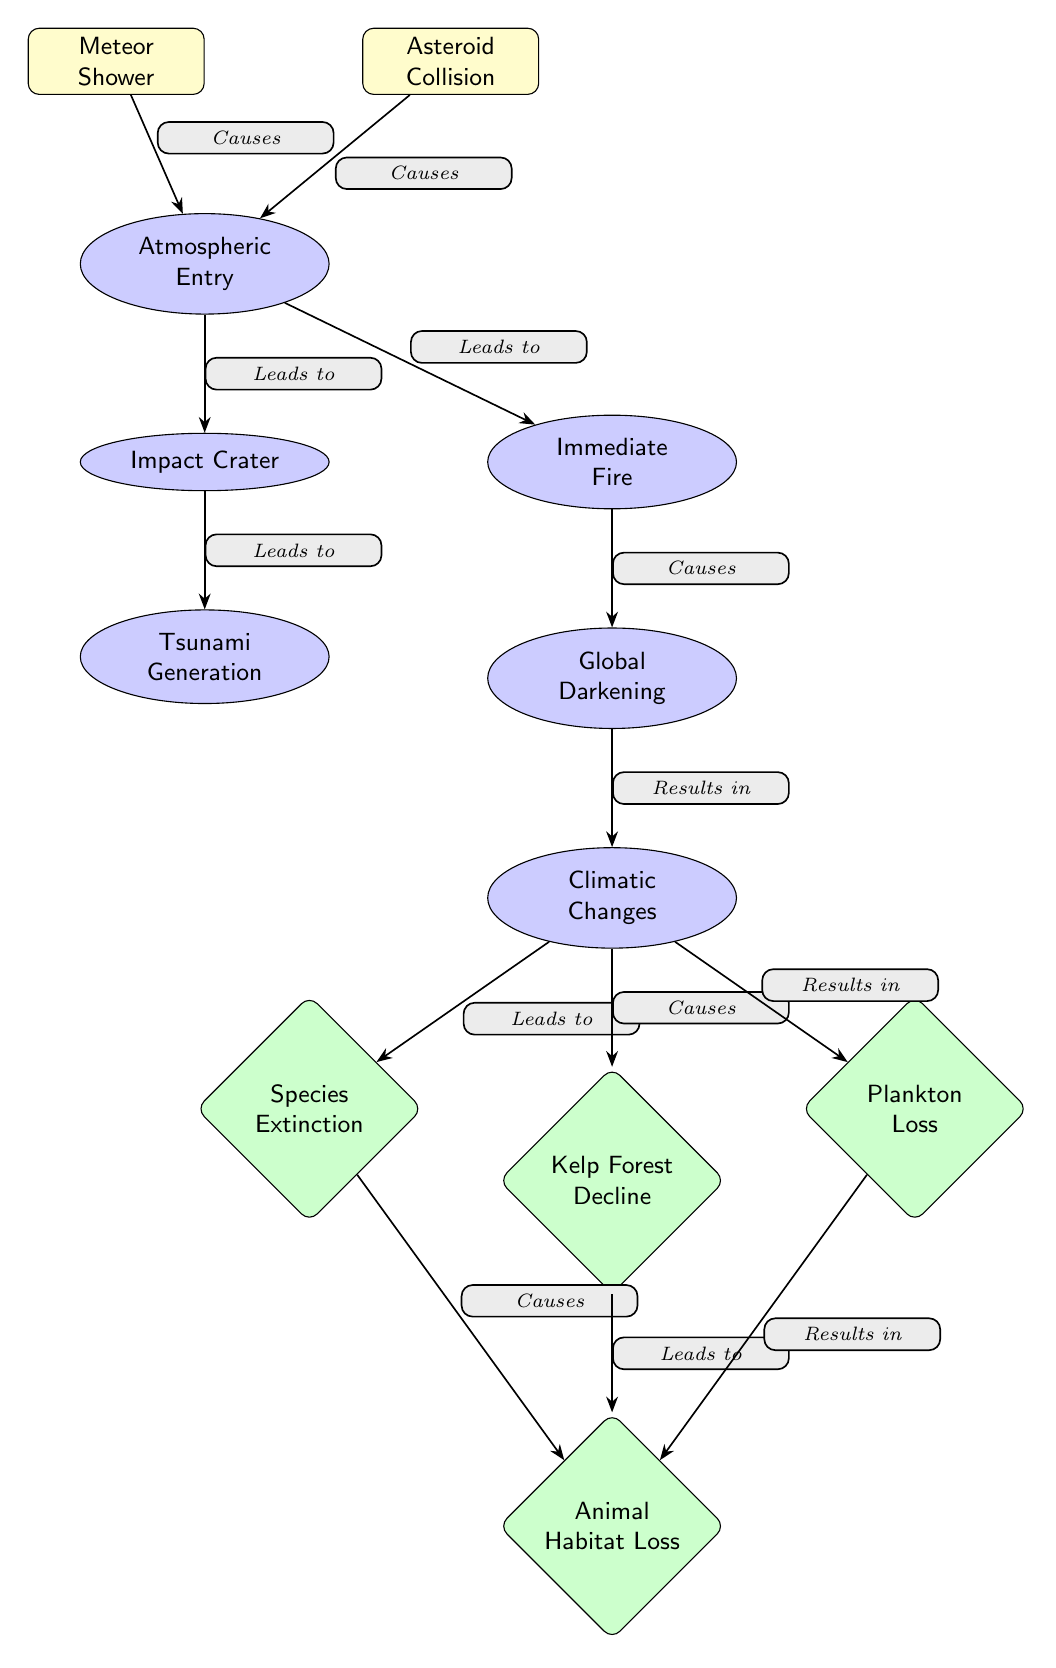What causes atmospheric entry? The diagram shows that both meteor showers and asteroid collisions lead to atmospheric entry, as indicated by the arrows pointing to the atmospheric entry node from both event nodes.
Answer: Meteor Shower and Asteroid Collision How many ecosystem impacts are mentioned? The diagram displays three distinct ecosystem impacts that result from climatic changes: species extinction, kelp forest decline, and plankton loss. Therefore, by counting these nodes, we find there are a total of three mentions of ecosystem impacts.
Answer: 3 What follows immediately after 'impact crater'? According to the diagram, the consequence that follows immediately after the 'impact crater' node is the 'tsunami generation' node, which is directly connected by the arrow.
Answer: Tsunami Generation What leads to global darkening? The diagram illustrates that 'immediate fire' causes 'global darkening', as shown by the arrow connecting these two nodes.
Answer: Immediate Fire Which ecosystem impact is caused by plankton loss? The diagram indicates that plankton loss results in habitat loss, as demonstrated by the arrow flowing from the plankton node to the habitat loss node.
Answer: Habitat Loss What is the effect of climatic changes? Climatic changes lead to species extinction, kelp forest decline, and plankton loss as indicated by the arrows connected from the climate node to each of those ecosystem impact nodes.
Answer: Species Extinction, Kelp Forest Decline, Plankton Loss 